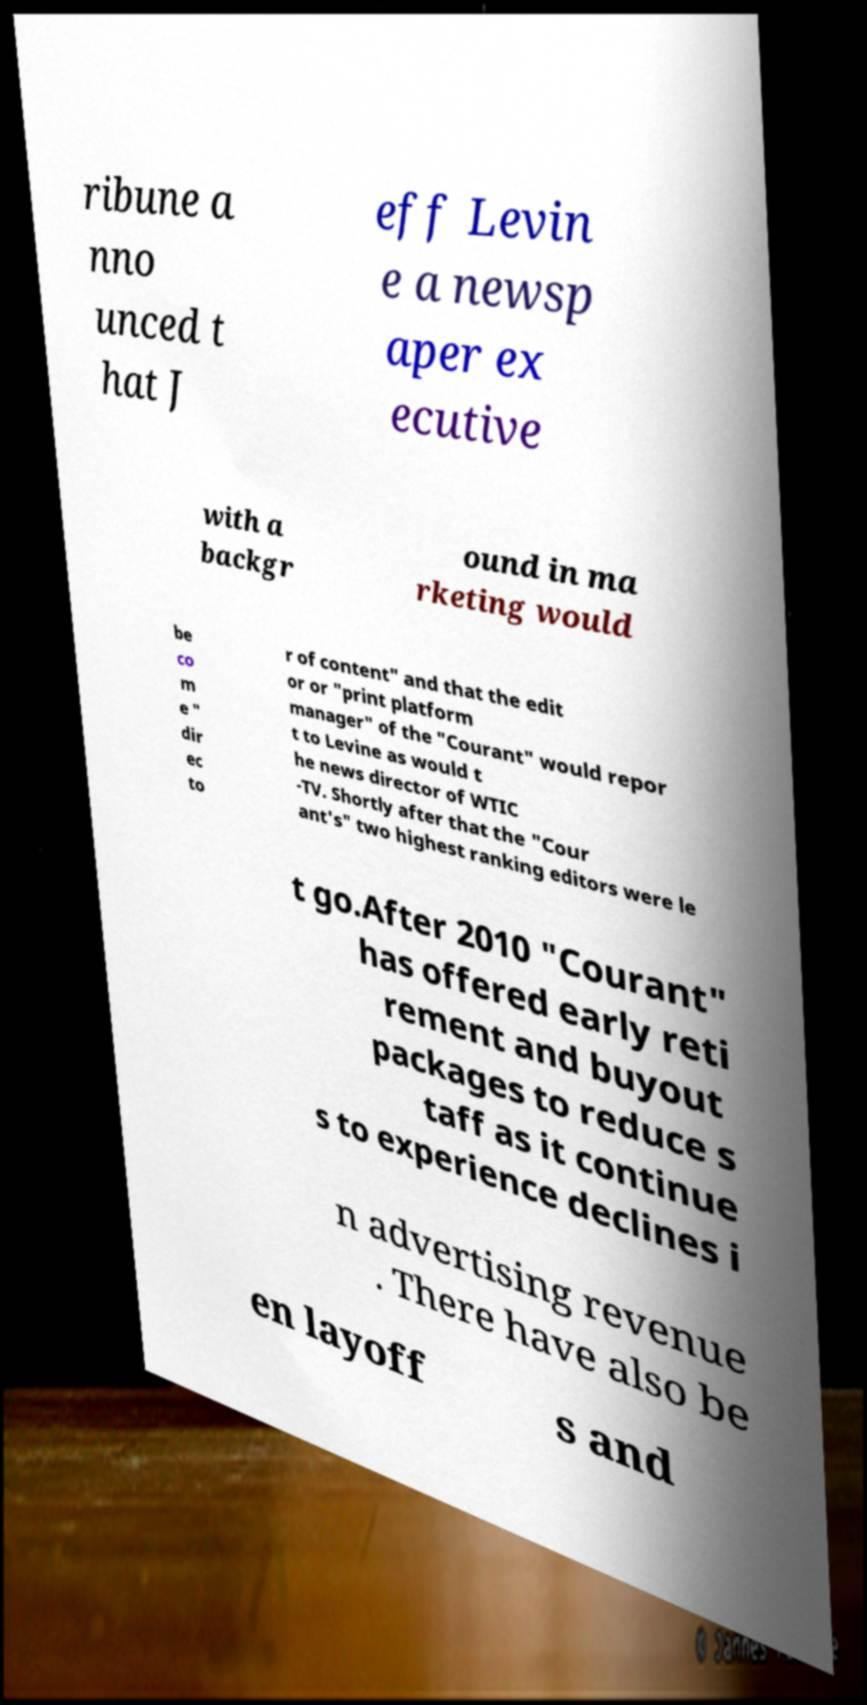Could you extract and type out the text from this image? ribune a nno unced t hat J eff Levin e a newsp aper ex ecutive with a backgr ound in ma rketing would be co m e " dir ec to r of content" and that the edit or or "print platform manager" of the "Courant" would repor t to Levine as would t he news director of WTIC -TV. Shortly after that the "Cour ant's" two highest ranking editors were le t go.After 2010 "Courant" has offered early reti rement and buyout packages to reduce s taff as it continue s to experience declines i n advertising revenue . There have also be en layoff s and 